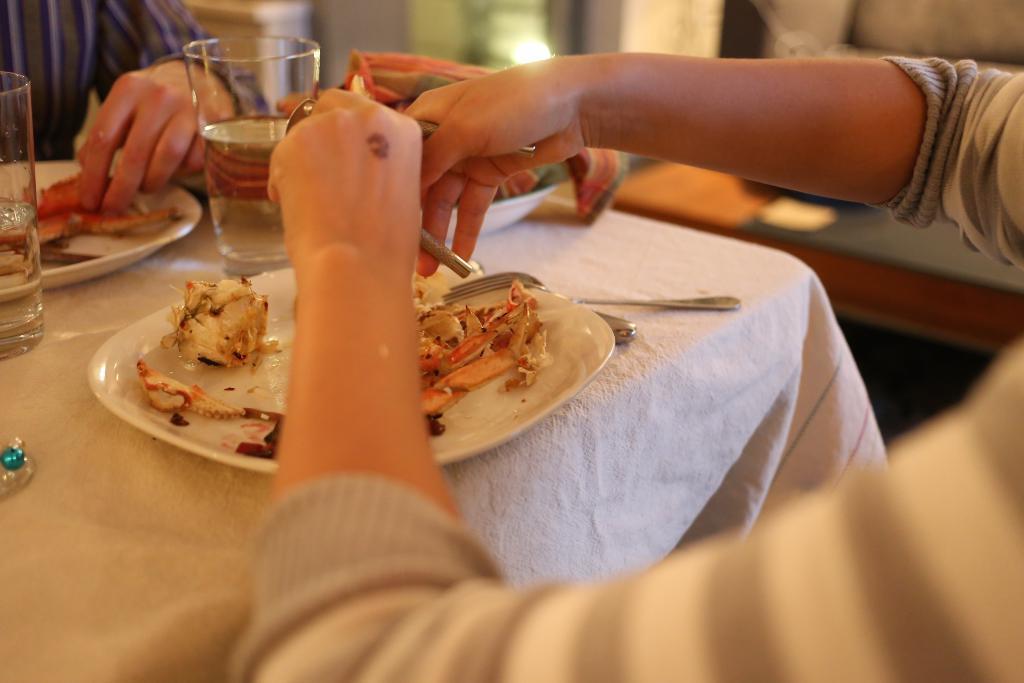Can you describe this image briefly? In this image there is a table with some food items on the plate and there are two glasses of water, beside that there is a bowl with a cloth on it, there are a spoon and a fork. On the left and right of the table there are two people sitting, one of them is holding an object and the other one is taking food from the plate. The background is blurry. 